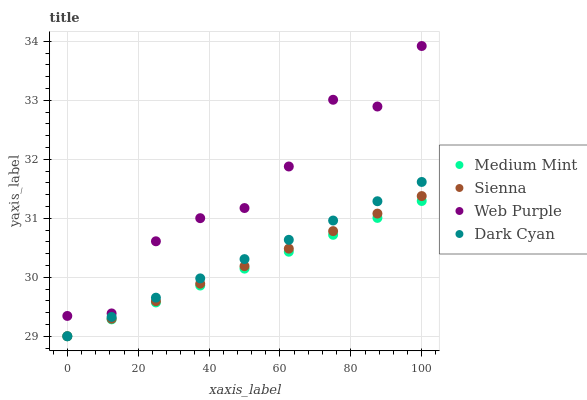Does Medium Mint have the minimum area under the curve?
Answer yes or no. Yes. Does Web Purple have the maximum area under the curve?
Answer yes or no. Yes. Does Sienna have the minimum area under the curve?
Answer yes or no. No. Does Sienna have the maximum area under the curve?
Answer yes or no. No. Is Dark Cyan the smoothest?
Answer yes or no. Yes. Is Web Purple the roughest?
Answer yes or no. Yes. Is Sienna the smoothest?
Answer yes or no. No. Is Sienna the roughest?
Answer yes or no. No. Does Medium Mint have the lowest value?
Answer yes or no. Yes. Does Web Purple have the lowest value?
Answer yes or no. No. Does Web Purple have the highest value?
Answer yes or no. Yes. Does Sienna have the highest value?
Answer yes or no. No. Is Sienna less than Web Purple?
Answer yes or no. Yes. Is Web Purple greater than Dark Cyan?
Answer yes or no. Yes. Does Dark Cyan intersect Sienna?
Answer yes or no. Yes. Is Dark Cyan less than Sienna?
Answer yes or no. No. Is Dark Cyan greater than Sienna?
Answer yes or no. No. Does Sienna intersect Web Purple?
Answer yes or no. No. 